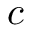Convert formula to latex. <formula><loc_0><loc_0><loc_500><loc_500>c</formula> 